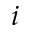Convert formula to latex. <formula><loc_0><loc_0><loc_500><loc_500>i</formula> 